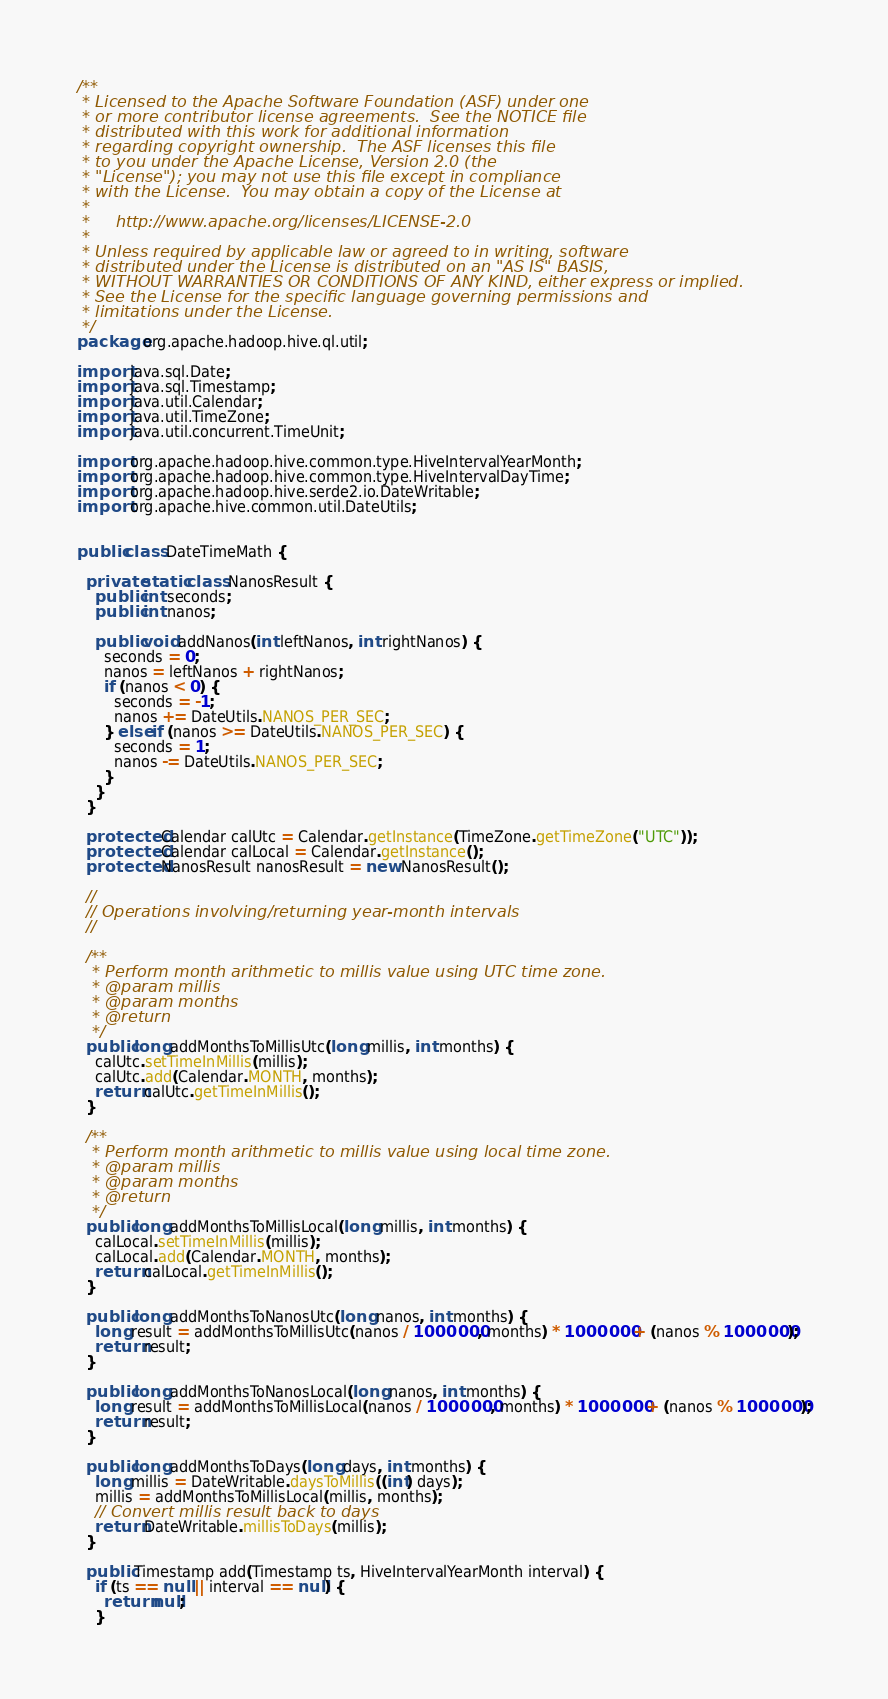<code> <loc_0><loc_0><loc_500><loc_500><_Java_>/**
 * Licensed to the Apache Software Foundation (ASF) under one
 * or more contributor license agreements.  See the NOTICE file
 * distributed with this work for additional information
 * regarding copyright ownership.  The ASF licenses this file
 * to you under the Apache License, Version 2.0 (the
 * "License"); you may not use this file except in compliance
 * with the License.  You may obtain a copy of the License at
 *
 *     http://www.apache.org/licenses/LICENSE-2.0
 *
 * Unless required by applicable law or agreed to in writing, software
 * distributed under the License is distributed on an "AS IS" BASIS,
 * WITHOUT WARRANTIES OR CONDITIONS OF ANY KIND, either express or implied.
 * See the License for the specific language governing permissions and
 * limitations under the License.
 */
package org.apache.hadoop.hive.ql.util;

import java.sql.Date;
import java.sql.Timestamp;
import java.util.Calendar;
import java.util.TimeZone;
import java.util.concurrent.TimeUnit;

import org.apache.hadoop.hive.common.type.HiveIntervalYearMonth;
import org.apache.hadoop.hive.common.type.HiveIntervalDayTime;
import org.apache.hadoop.hive.serde2.io.DateWritable;
import org.apache.hive.common.util.DateUtils;


public class DateTimeMath {

  private static class NanosResult {
    public int seconds;
    public int nanos;

    public void addNanos(int leftNanos, int rightNanos) {
      seconds = 0;
      nanos = leftNanos + rightNanos;
      if (nanos < 0) {
        seconds = -1;
        nanos += DateUtils.NANOS_PER_SEC;
      } else if (nanos >= DateUtils.NANOS_PER_SEC) {
        seconds = 1;
        nanos -= DateUtils.NANOS_PER_SEC;
      }
    }
  }

  protected Calendar calUtc = Calendar.getInstance(TimeZone.getTimeZone("UTC"));
  protected Calendar calLocal = Calendar.getInstance();
  protected NanosResult nanosResult = new NanosResult();

  //
  // Operations involving/returning year-month intervals
  //

  /**
   * Perform month arithmetic to millis value using UTC time zone.
   * @param millis
   * @param months
   * @return
   */
  public long addMonthsToMillisUtc(long millis, int months) {
    calUtc.setTimeInMillis(millis);
    calUtc.add(Calendar.MONTH, months);
    return calUtc.getTimeInMillis();
  }

  /**
   * Perform month arithmetic to millis value using local time zone.
   * @param millis
   * @param months
   * @return
   */
  public long addMonthsToMillisLocal(long millis, int months) {
    calLocal.setTimeInMillis(millis);
    calLocal.add(Calendar.MONTH, months);
    return calLocal.getTimeInMillis();
  }

  public long addMonthsToNanosUtc(long nanos, int months) {
    long result = addMonthsToMillisUtc(nanos / 1000000, months) * 1000000 + (nanos % 1000000);
    return result;
  }

  public long addMonthsToNanosLocal(long nanos, int months) {
    long result = addMonthsToMillisLocal(nanos / 1000000, months) * 1000000 + (nanos % 1000000);
    return result;
  }

  public long addMonthsToDays(long days, int months) {
    long millis = DateWritable.daysToMillis((int) days);
    millis = addMonthsToMillisLocal(millis, months);
    // Convert millis result back to days
    return DateWritable.millisToDays(millis);
  }

  public Timestamp add(Timestamp ts, HiveIntervalYearMonth interval) {
    if (ts == null || interval == null) {
      return null;
    }
</code> 